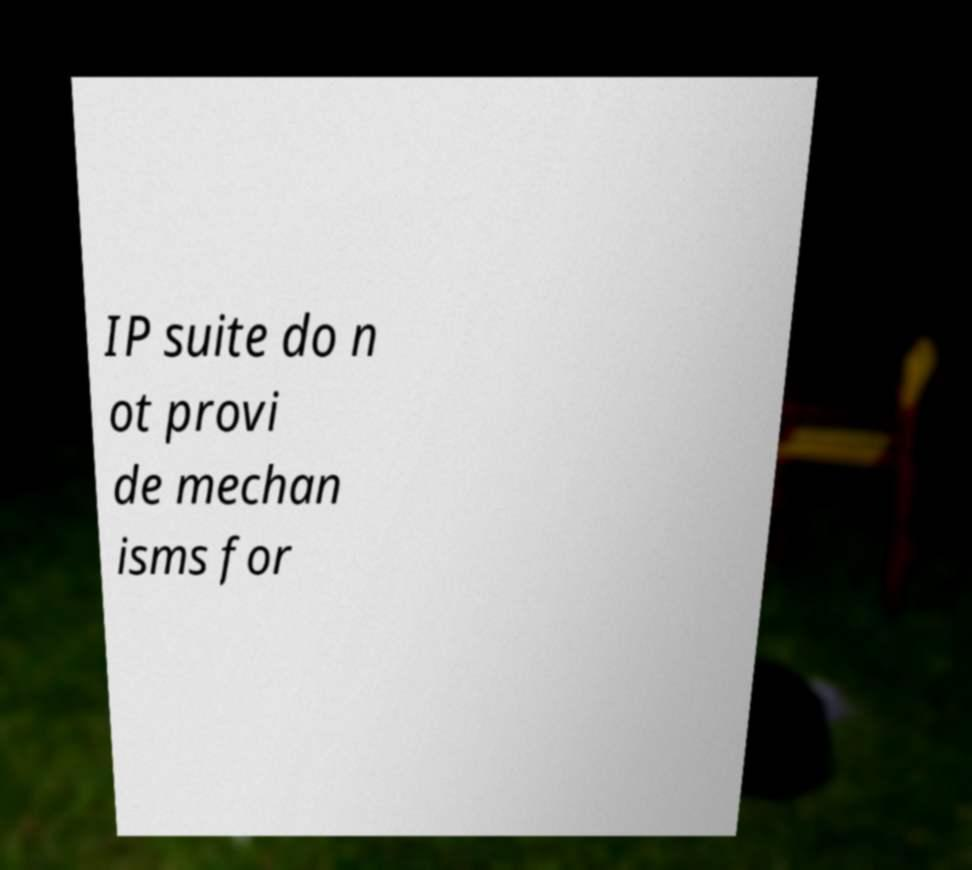For documentation purposes, I need the text within this image transcribed. Could you provide that? IP suite do n ot provi de mechan isms for 